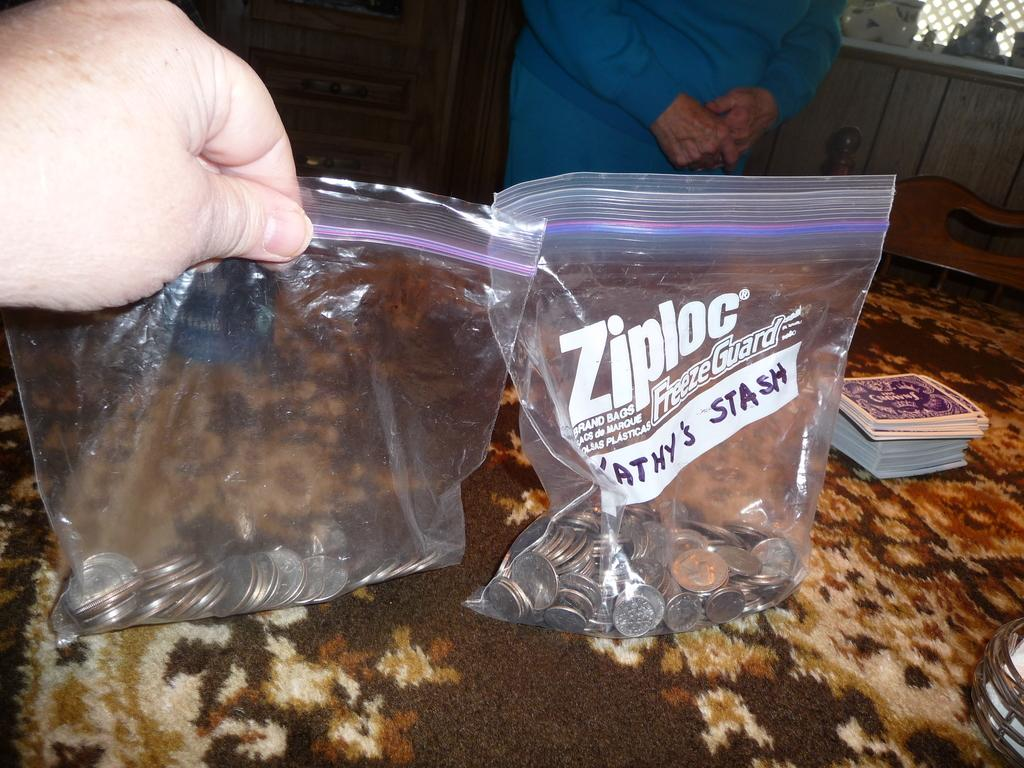What type of objects are contained within the covers in the image? There are coins in covers in the image. What other items can be seen in the image? There are cards in the image. What is located on the table in the image? There is an item on the table in the image. Who is holding a cover of coins in the image? A person is holding a cover of coins in the image. What can be seen in the background of the image? There is a chair and a person standing in the background of the image. What type of pleasure can be seen on the faces of the girls in the image? There are no girls present in the image, so we cannot determine the type of pleasure on their faces. What type of magic is being performed by the person in the image? There is no indication of magic or any magical activity in the image. 